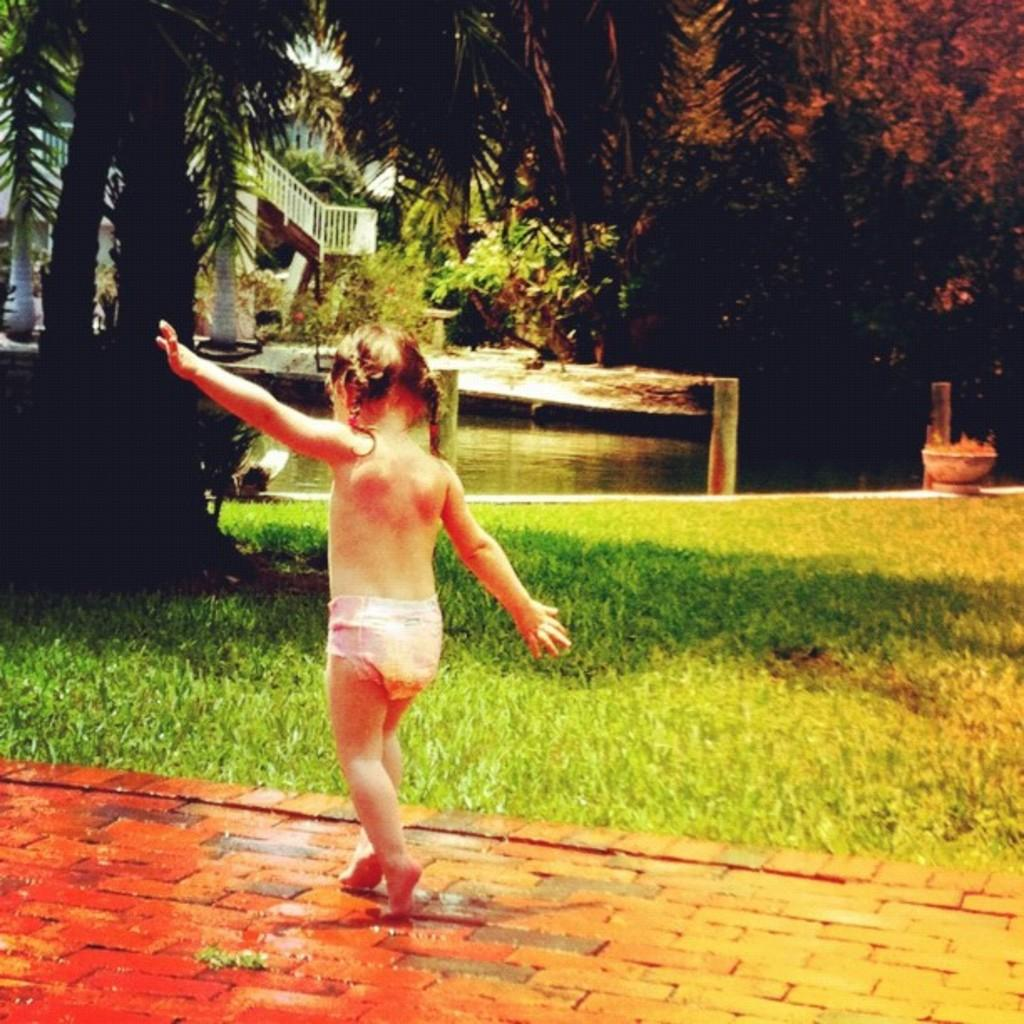What is the main subject of the image? There is a girl walking in the image. What is at the bottom of the image? There is a walkway at the bottom of the image. What type of vegetation is present in the image? There is grass in the image. What structures can be seen in the background of the image? There is a house, a railing, and trees in the background of the image. What body of water is visible in the background of the image? There is a pond in the background of the image. What other unspecified objects can be seen in the background of the image? There are some unspecified objects in the background of the image. What type of stomach can be seen in the image? There is no stomach present in the image. 